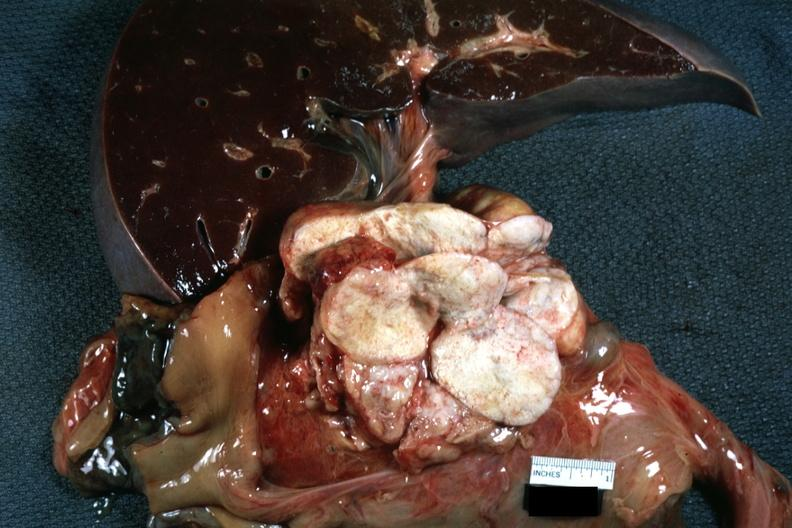what is present?
Answer the question using a single word or phrase. Lymph node 